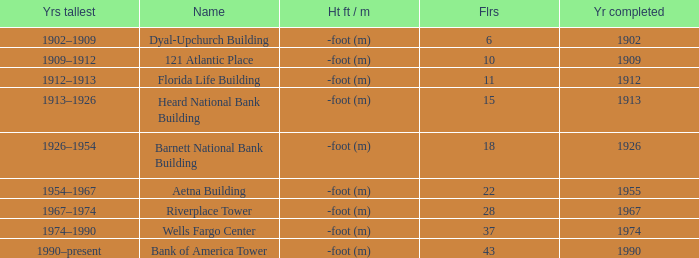What year was the building completed that has 10 floors? 1909.0. 